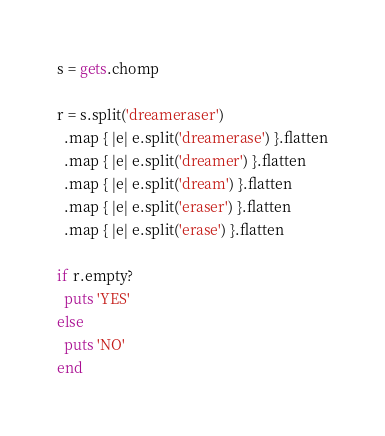Convert code to text. <code><loc_0><loc_0><loc_500><loc_500><_Ruby_>s = gets.chomp

r = s.split('dreameraser')
  .map { |e| e.split('dreamerase') }.flatten
  .map { |e| e.split('dreamer') }.flatten
  .map { |e| e.split('dream') }.flatten
  .map { |e| e.split('eraser') }.flatten
  .map { |e| e.split('erase') }.flatten

if r.empty?
  puts 'YES'
else
  puts 'NO'
end
</code> 